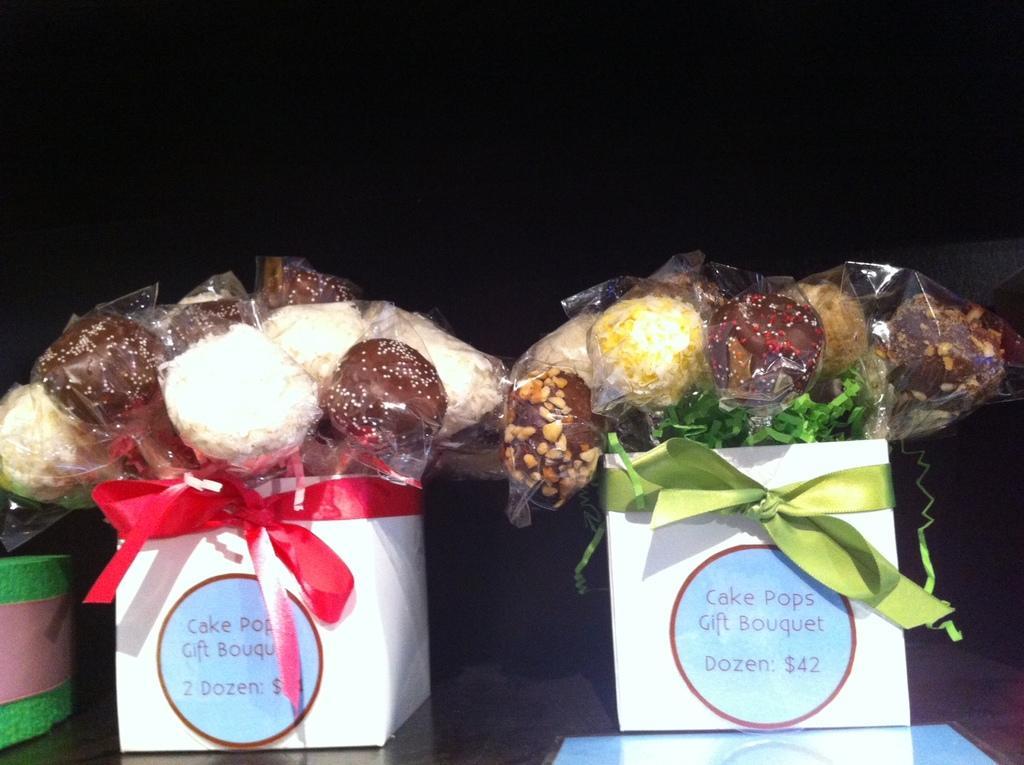Please provide a concise description of this image. In this picture we can see some eatable things are placed in a boxes. 